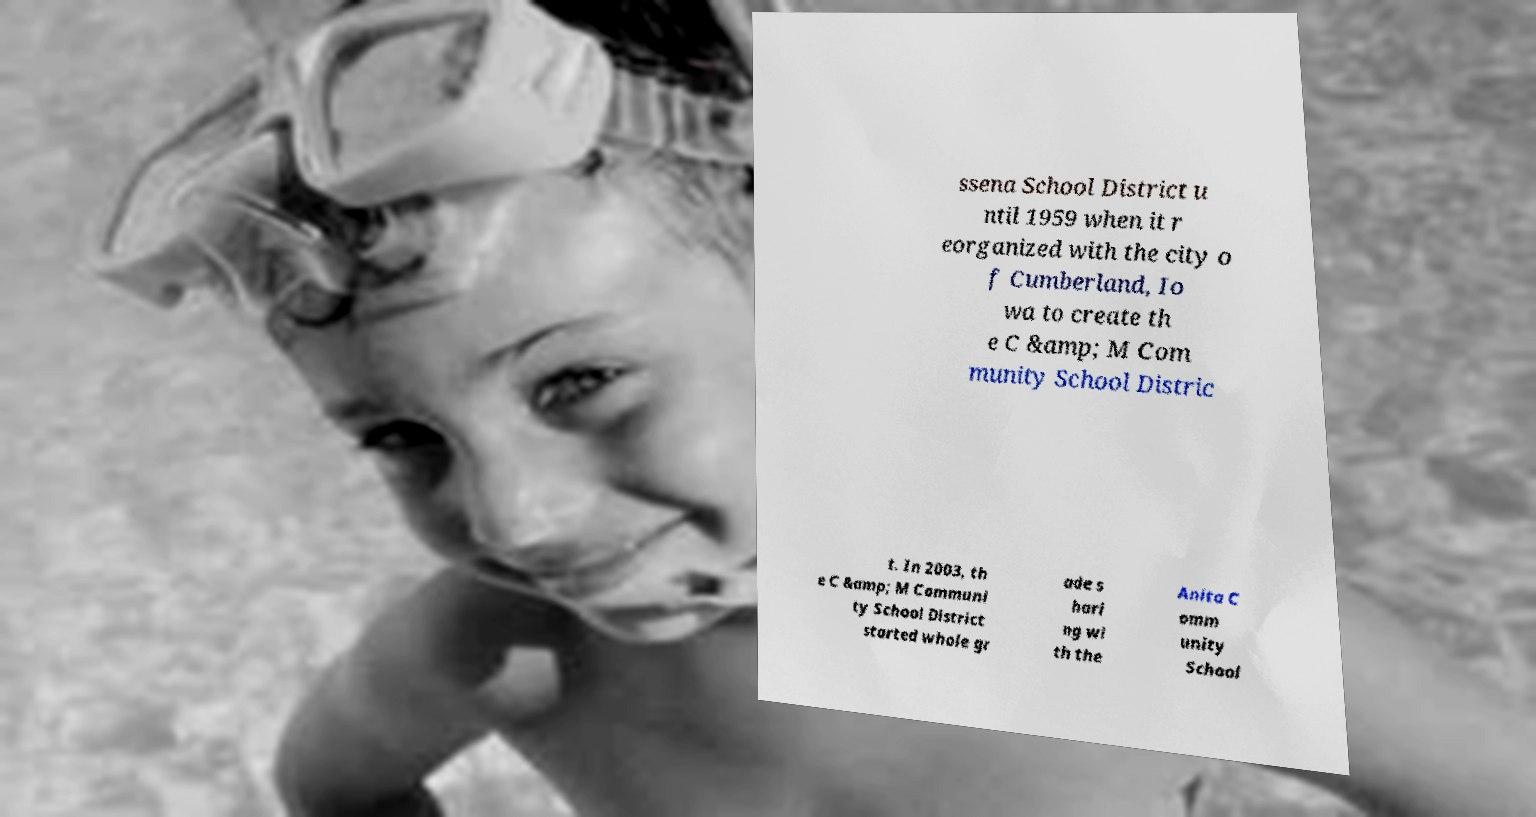Could you extract and type out the text from this image? ssena School District u ntil 1959 when it r eorganized with the city o f Cumberland, Io wa to create th e C &amp; M Com munity School Distric t. In 2003, th e C &amp; M Communi ty School District started whole gr ade s hari ng wi th the Anita C omm unity School 